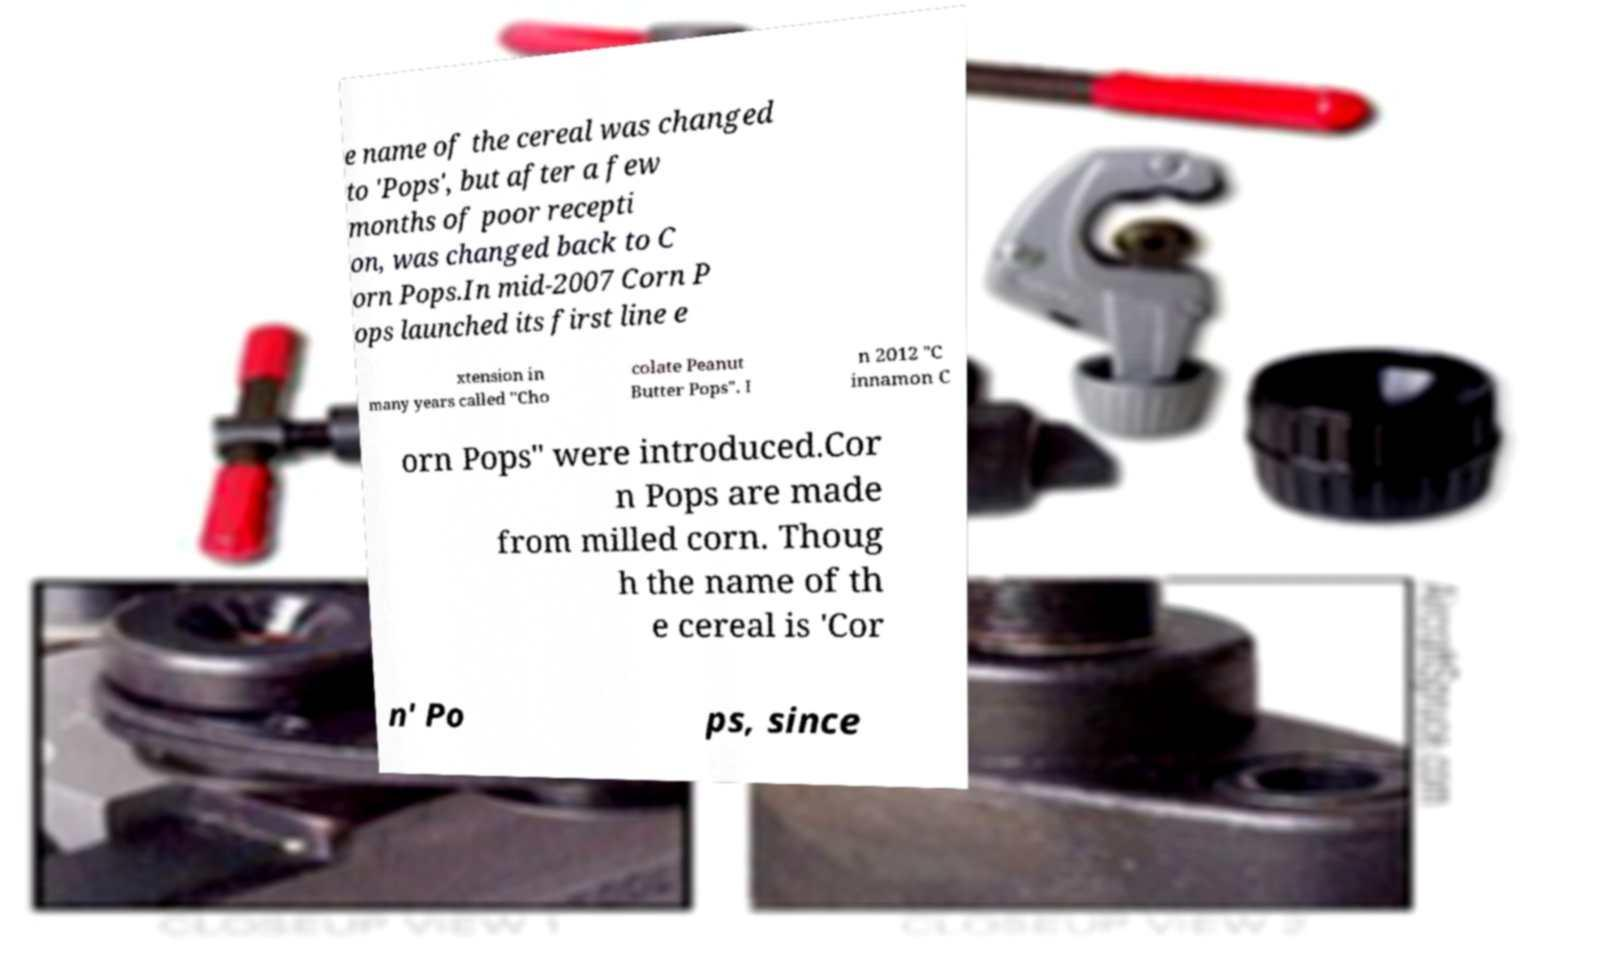Can you accurately transcribe the text from the provided image for me? e name of the cereal was changed to 'Pops', but after a few months of poor recepti on, was changed back to C orn Pops.In mid-2007 Corn P ops launched its first line e xtension in many years called "Cho colate Peanut Butter Pops". I n 2012 "C innamon C orn Pops" were introduced.Cor n Pops are made from milled corn. Thoug h the name of th e cereal is 'Cor n' Po ps, since 